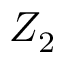Convert formula to latex. <formula><loc_0><loc_0><loc_500><loc_500>Z _ { 2 }</formula> 